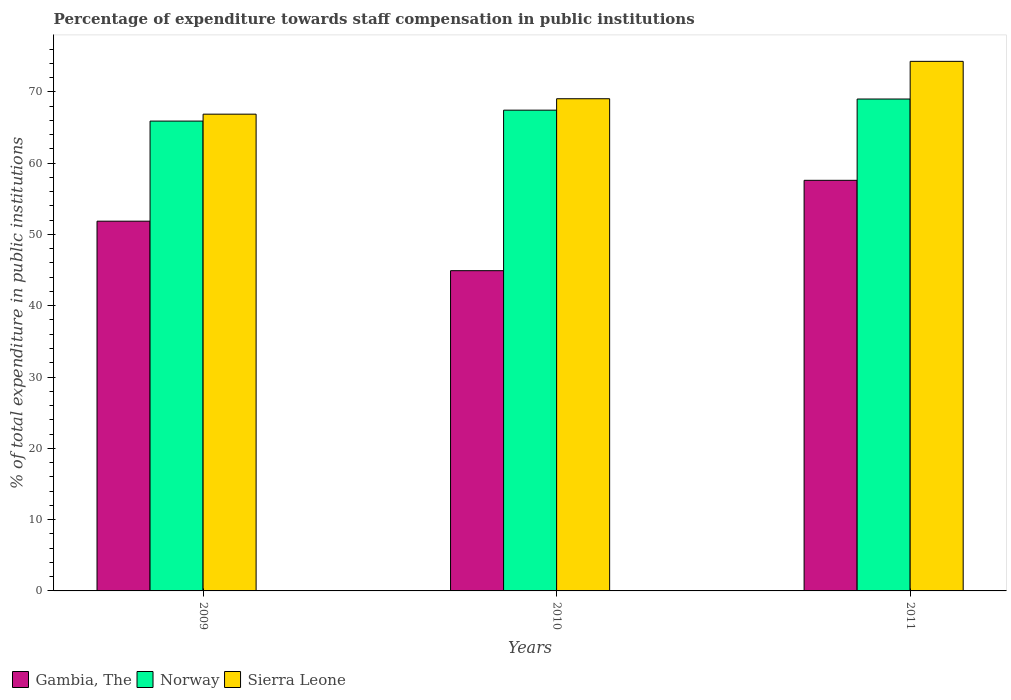How many groups of bars are there?
Make the answer very short. 3. Are the number of bars per tick equal to the number of legend labels?
Offer a terse response. Yes. Are the number of bars on each tick of the X-axis equal?
Provide a short and direct response. Yes. How many bars are there on the 2nd tick from the right?
Provide a short and direct response. 3. In how many cases, is the number of bars for a given year not equal to the number of legend labels?
Ensure brevity in your answer.  0. What is the percentage of expenditure towards staff compensation in Norway in 2010?
Keep it short and to the point. 67.42. Across all years, what is the maximum percentage of expenditure towards staff compensation in Norway?
Ensure brevity in your answer.  68.99. Across all years, what is the minimum percentage of expenditure towards staff compensation in Gambia, The?
Make the answer very short. 44.91. In which year was the percentage of expenditure towards staff compensation in Sierra Leone maximum?
Ensure brevity in your answer.  2011. In which year was the percentage of expenditure towards staff compensation in Sierra Leone minimum?
Offer a terse response. 2009. What is the total percentage of expenditure towards staff compensation in Norway in the graph?
Your answer should be very brief. 202.3. What is the difference between the percentage of expenditure towards staff compensation in Norway in 2010 and that in 2011?
Provide a succinct answer. -1.56. What is the difference between the percentage of expenditure towards staff compensation in Sierra Leone in 2011 and the percentage of expenditure towards staff compensation in Gambia, The in 2009?
Your answer should be very brief. 22.42. What is the average percentage of expenditure towards staff compensation in Gambia, The per year?
Give a very brief answer. 51.45. In the year 2009, what is the difference between the percentage of expenditure towards staff compensation in Norway and percentage of expenditure towards staff compensation in Sierra Leone?
Ensure brevity in your answer.  -0.97. In how many years, is the percentage of expenditure towards staff compensation in Sierra Leone greater than 8 %?
Keep it short and to the point. 3. What is the ratio of the percentage of expenditure towards staff compensation in Sierra Leone in 2009 to that in 2011?
Offer a terse response. 0.9. Is the percentage of expenditure towards staff compensation in Gambia, The in 2010 less than that in 2011?
Your answer should be very brief. Yes. Is the difference between the percentage of expenditure towards staff compensation in Norway in 2010 and 2011 greater than the difference between the percentage of expenditure towards staff compensation in Sierra Leone in 2010 and 2011?
Offer a terse response. Yes. What is the difference between the highest and the second highest percentage of expenditure towards staff compensation in Sierra Leone?
Give a very brief answer. 5.24. What is the difference between the highest and the lowest percentage of expenditure towards staff compensation in Gambia, The?
Give a very brief answer. 12.67. Is the sum of the percentage of expenditure towards staff compensation in Norway in 2010 and 2011 greater than the maximum percentage of expenditure towards staff compensation in Gambia, The across all years?
Give a very brief answer. Yes. What does the 1st bar from the left in 2011 represents?
Keep it short and to the point. Gambia, The. What does the 3rd bar from the right in 2009 represents?
Keep it short and to the point. Gambia, The. Is it the case that in every year, the sum of the percentage of expenditure towards staff compensation in Gambia, The and percentage of expenditure towards staff compensation in Sierra Leone is greater than the percentage of expenditure towards staff compensation in Norway?
Your response must be concise. Yes. How many bars are there?
Offer a very short reply. 9. Are all the bars in the graph horizontal?
Ensure brevity in your answer.  No. How many years are there in the graph?
Your response must be concise. 3. Are the values on the major ticks of Y-axis written in scientific E-notation?
Provide a short and direct response. No. Does the graph contain grids?
Your response must be concise. No. How many legend labels are there?
Ensure brevity in your answer.  3. What is the title of the graph?
Provide a succinct answer. Percentage of expenditure towards staff compensation in public institutions. What is the label or title of the X-axis?
Your response must be concise. Years. What is the label or title of the Y-axis?
Provide a succinct answer. % of total expenditure in public institutions. What is the % of total expenditure in public institutions in Gambia, The in 2009?
Offer a very short reply. 51.85. What is the % of total expenditure in public institutions in Norway in 2009?
Make the answer very short. 65.89. What is the % of total expenditure in public institutions in Sierra Leone in 2009?
Your answer should be very brief. 66.86. What is the % of total expenditure in public institutions in Gambia, The in 2010?
Your answer should be very brief. 44.91. What is the % of total expenditure in public institutions in Norway in 2010?
Ensure brevity in your answer.  67.42. What is the % of total expenditure in public institutions of Sierra Leone in 2010?
Give a very brief answer. 69.03. What is the % of total expenditure in public institutions in Gambia, The in 2011?
Offer a very short reply. 57.58. What is the % of total expenditure in public institutions in Norway in 2011?
Your answer should be very brief. 68.99. What is the % of total expenditure in public institutions of Sierra Leone in 2011?
Provide a short and direct response. 74.27. Across all years, what is the maximum % of total expenditure in public institutions of Gambia, The?
Ensure brevity in your answer.  57.58. Across all years, what is the maximum % of total expenditure in public institutions of Norway?
Keep it short and to the point. 68.99. Across all years, what is the maximum % of total expenditure in public institutions in Sierra Leone?
Provide a succinct answer. 74.27. Across all years, what is the minimum % of total expenditure in public institutions of Gambia, The?
Offer a terse response. 44.91. Across all years, what is the minimum % of total expenditure in public institutions in Norway?
Your answer should be very brief. 65.89. Across all years, what is the minimum % of total expenditure in public institutions in Sierra Leone?
Give a very brief answer. 66.86. What is the total % of total expenditure in public institutions of Gambia, The in the graph?
Offer a terse response. 154.35. What is the total % of total expenditure in public institutions in Norway in the graph?
Your answer should be compact. 202.3. What is the total % of total expenditure in public institutions in Sierra Leone in the graph?
Ensure brevity in your answer.  210.16. What is the difference between the % of total expenditure in public institutions in Gambia, The in 2009 and that in 2010?
Offer a terse response. 6.94. What is the difference between the % of total expenditure in public institutions in Norway in 2009 and that in 2010?
Offer a very short reply. -1.53. What is the difference between the % of total expenditure in public institutions in Sierra Leone in 2009 and that in 2010?
Ensure brevity in your answer.  -2.16. What is the difference between the % of total expenditure in public institutions in Gambia, The in 2009 and that in 2011?
Provide a succinct answer. -5.73. What is the difference between the % of total expenditure in public institutions of Norway in 2009 and that in 2011?
Give a very brief answer. -3.09. What is the difference between the % of total expenditure in public institutions in Sierra Leone in 2009 and that in 2011?
Your answer should be compact. -7.41. What is the difference between the % of total expenditure in public institutions of Gambia, The in 2010 and that in 2011?
Provide a succinct answer. -12.67. What is the difference between the % of total expenditure in public institutions of Norway in 2010 and that in 2011?
Your answer should be compact. -1.56. What is the difference between the % of total expenditure in public institutions in Sierra Leone in 2010 and that in 2011?
Your answer should be very brief. -5.24. What is the difference between the % of total expenditure in public institutions of Gambia, The in 2009 and the % of total expenditure in public institutions of Norway in 2010?
Keep it short and to the point. -15.57. What is the difference between the % of total expenditure in public institutions of Gambia, The in 2009 and the % of total expenditure in public institutions of Sierra Leone in 2010?
Offer a very short reply. -17.17. What is the difference between the % of total expenditure in public institutions of Norway in 2009 and the % of total expenditure in public institutions of Sierra Leone in 2010?
Give a very brief answer. -3.13. What is the difference between the % of total expenditure in public institutions in Gambia, The in 2009 and the % of total expenditure in public institutions in Norway in 2011?
Ensure brevity in your answer.  -17.13. What is the difference between the % of total expenditure in public institutions in Gambia, The in 2009 and the % of total expenditure in public institutions in Sierra Leone in 2011?
Provide a short and direct response. -22.42. What is the difference between the % of total expenditure in public institutions in Norway in 2009 and the % of total expenditure in public institutions in Sierra Leone in 2011?
Keep it short and to the point. -8.38. What is the difference between the % of total expenditure in public institutions in Gambia, The in 2010 and the % of total expenditure in public institutions in Norway in 2011?
Ensure brevity in your answer.  -24.07. What is the difference between the % of total expenditure in public institutions in Gambia, The in 2010 and the % of total expenditure in public institutions in Sierra Leone in 2011?
Your answer should be very brief. -29.36. What is the difference between the % of total expenditure in public institutions in Norway in 2010 and the % of total expenditure in public institutions in Sierra Leone in 2011?
Your answer should be compact. -6.85. What is the average % of total expenditure in public institutions of Gambia, The per year?
Make the answer very short. 51.45. What is the average % of total expenditure in public institutions of Norway per year?
Make the answer very short. 67.43. What is the average % of total expenditure in public institutions in Sierra Leone per year?
Keep it short and to the point. 70.05. In the year 2009, what is the difference between the % of total expenditure in public institutions in Gambia, The and % of total expenditure in public institutions in Norway?
Ensure brevity in your answer.  -14.04. In the year 2009, what is the difference between the % of total expenditure in public institutions in Gambia, The and % of total expenditure in public institutions in Sierra Leone?
Give a very brief answer. -15.01. In the year 2009, what is the difference between the % of total expenditure in public institutions in Norway and % of total expenditure in public institutions in Sierra Leone?
Offer a terse response. -0.97. In the year 2010, what is the difference between the % of total expenditure in public institutions in Gambia, The and % of total expenditure in public institutions in Norway?
Your response must be concise. -22.51. In the year 2010, what is the difference between the % of total expenditure in public institutions in Gambia, The and % of total expenditure in public institutions in Sierra Leone?
Your response must be concise. -24.11. In the year 2010, what is the difference between the % of total expenditure in public institutions in Norway and % of total expenditure in public institutions in Sierra Leone?
Offer a terse response. -1.6. In the year 2011, what is the difference between the % of total expenditure in public institutions in Gambia, The and % of total expenditure in public institutions in Norway?
Give a very brief answer. -11.4. In the year 2011, what is the difference between the % of total expenditure in public institutions in Gambia, The and % of total expenditure in public institutions in Sierra Leone?
Offer a terse response. -16.68. In the year 2011, what is the difference between the % of total expenditure in public institutions of Norway and % of total expenditure in public institutions of Sierra Leone?
Your answer should be compact. -5.28. What is the ratio of the % of total expenditure in public institutions of Gambia, The in 2009 to that in 2010?
Your answer should be very brief. 1.15. What is the ratio of the % of total expenditure in public institutions in Norway in 2009 to that in 2010?
Your response must be concise. 0.98. What is the ratio of the % of total expenditure in public institutions of Sierra Leone in 2009 to that in 2010?
Your answer should be very brief. 0.97. What is the ratio of the % of total expenditure in public institutions in Gambia, The in 2009 to that in 2011?
Provide a succinct answer. 0.9. What is the ratio of the % of total expenditure in public institutions in Norway in 2009 to that in 2011?
Provide a succinct answer. 0.96. What is the ratio of the % of total expenditure in public institutions in Sierra Leone in 2009 to that in 2011?
Your answer should be very brief. 0.9. What is the ratio of the % of total expenditure in public institutions of Gambia, The in 2010 to that in 2011?
Ensure brevity in your answer.  0.78. What is the ratio of the % of total expenditure in public institutions of Norway in 2010 to that in 2011?
Keep it short and to the point. 0.98. What is the ratio of the % of total expenditure in public institutions of Sierra Leone in 2010 to that in 2011?
Keep it short and to the point. 0.93. What is the difference between the highest and the second highest % of total expenditure in public institutions of Gambia, The?
Keep it short and to the point. 5.73. What is the difference between the highest and the second highest % of total expenditure in public institutions in Norway?
Keep it short and to the point. 1.56. What is the difference between the highest and the second highest % of total expenditure in public institutions of Sierra Leone?
Make the answer very short. 5.24. What is the difference between the highest and the lowest % of total expenditure in public institutions in Gambia, The?
Your answer should be compact. 12.67. What is the difference between the highest and the lowest % of total expenditure in public institutions of Norway?
Your response must be concise. 3.09. What is the difference between the highest and the lowest % of total expenditure in public institutions in Sierra Leone?
Your response must be concise. 7.41. 